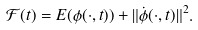<formula> <loc_0><loc_0><loc_500><loc_500>\mathcal { F } ( t ) = E ( \phi ( \cdot , t ) ) + \| \dot { \phi } ( \cdot , t ) \| ^ { 2 } .</formula> 